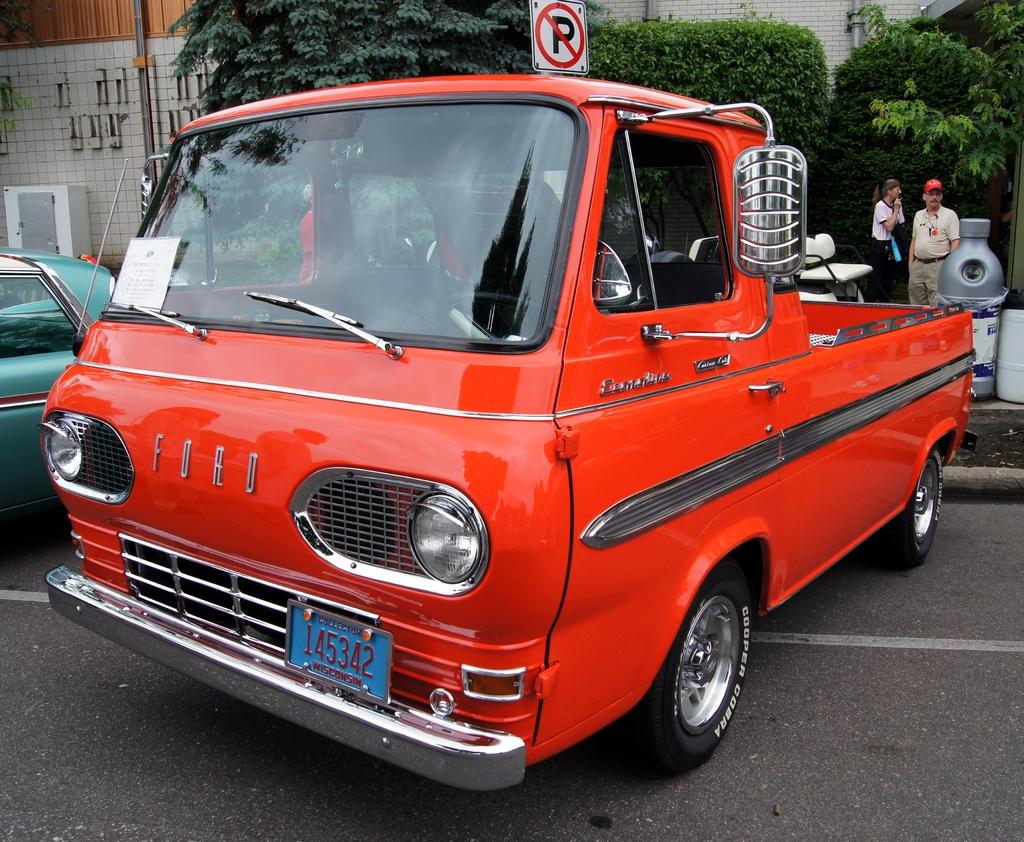What is the license plate number?
Ensure brevity in your answer.  145342. What is the brand of this vehicle?
Provide a succinct answer. Ford. 